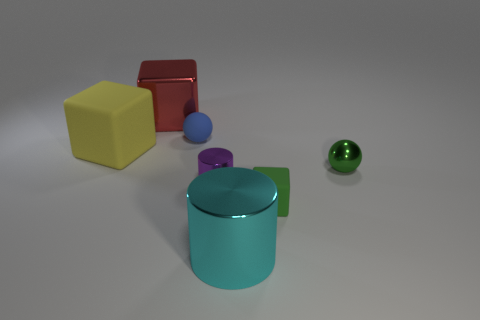There is a green thing that is the same shape as the red object; what size is it?
Your response must be concise. Small. There is a purple cylinder that is left of the small metallic thing that is on the right side of the cylinder that is behind the green block; what is it made of?
Ensure brevity in your answer.  Metal. What is the shape of the blue thing that is the same size as the purple object?
Offer a terse response. Sphere. What number of objects are either tiny yellow matte spheres or large things in front of the blue object?
Give a very brief answer. 2. Is the material of the large thing to the right of the red shiny cube the same as the sphere that is right of the cyan cylinder?
Your answer should be very brief. Yes. There is a small metallic thing that is the same color as the tiny matte block; what is its shape?
Provide a short and direct response. Sphere. How many blue things are rubber spheres or big rubber objects?
Your answer should be compact. 1. The matte sphere has what size?
Make the answer very short. Small. Are there more cylinders that are behind the tiny green rubber object than green spheres?
Offer a very short reply. No. There is a metallic block; how many tiny purple things are in front of it?
Your answer should be very brief. 1. 